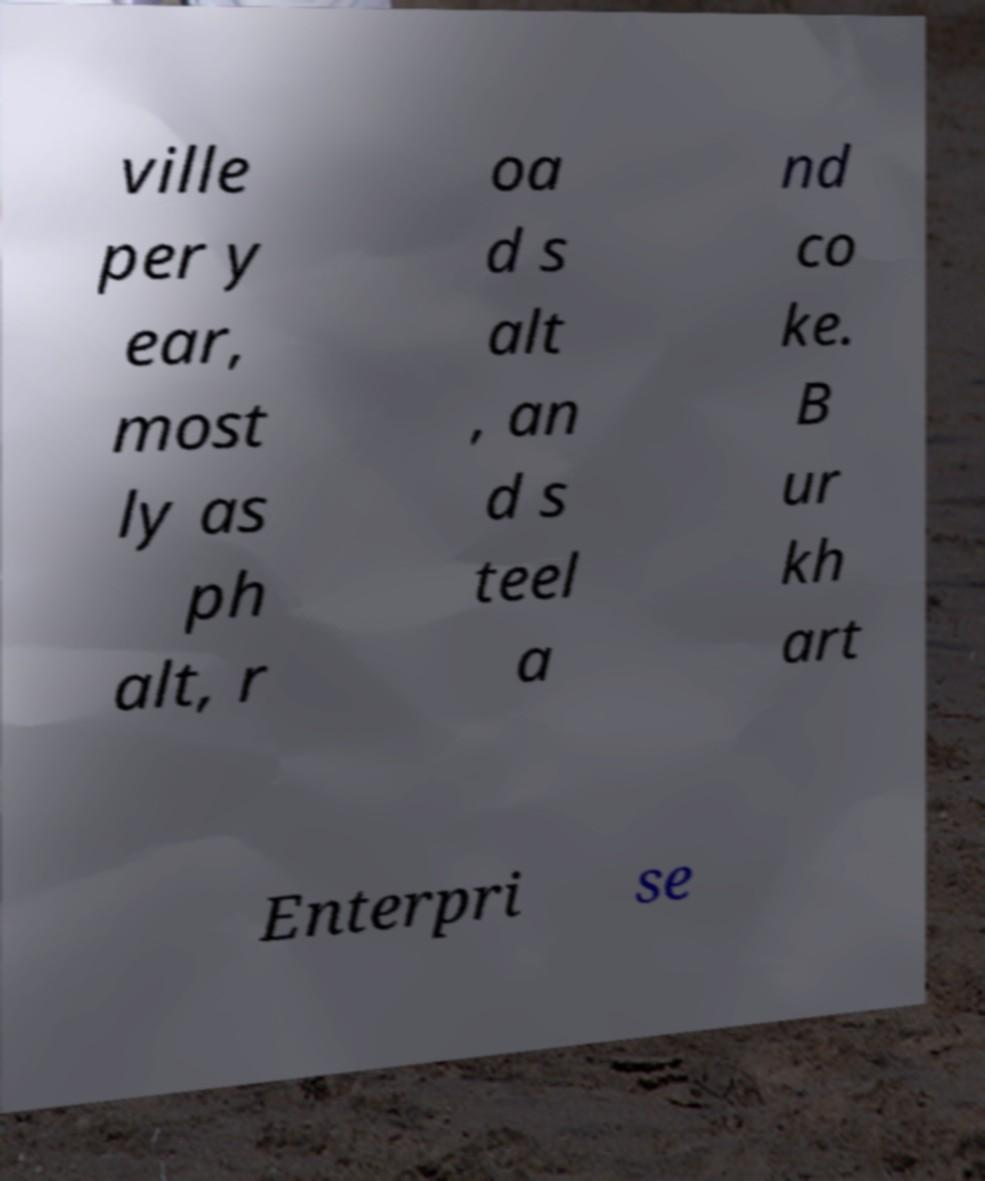Can you accurately transcribe the text from the provided image for me? ville per y ear, most ly as ph alt, r oa d s alt , an d s teel a nd co ke. B ur kh art Enterpri se 